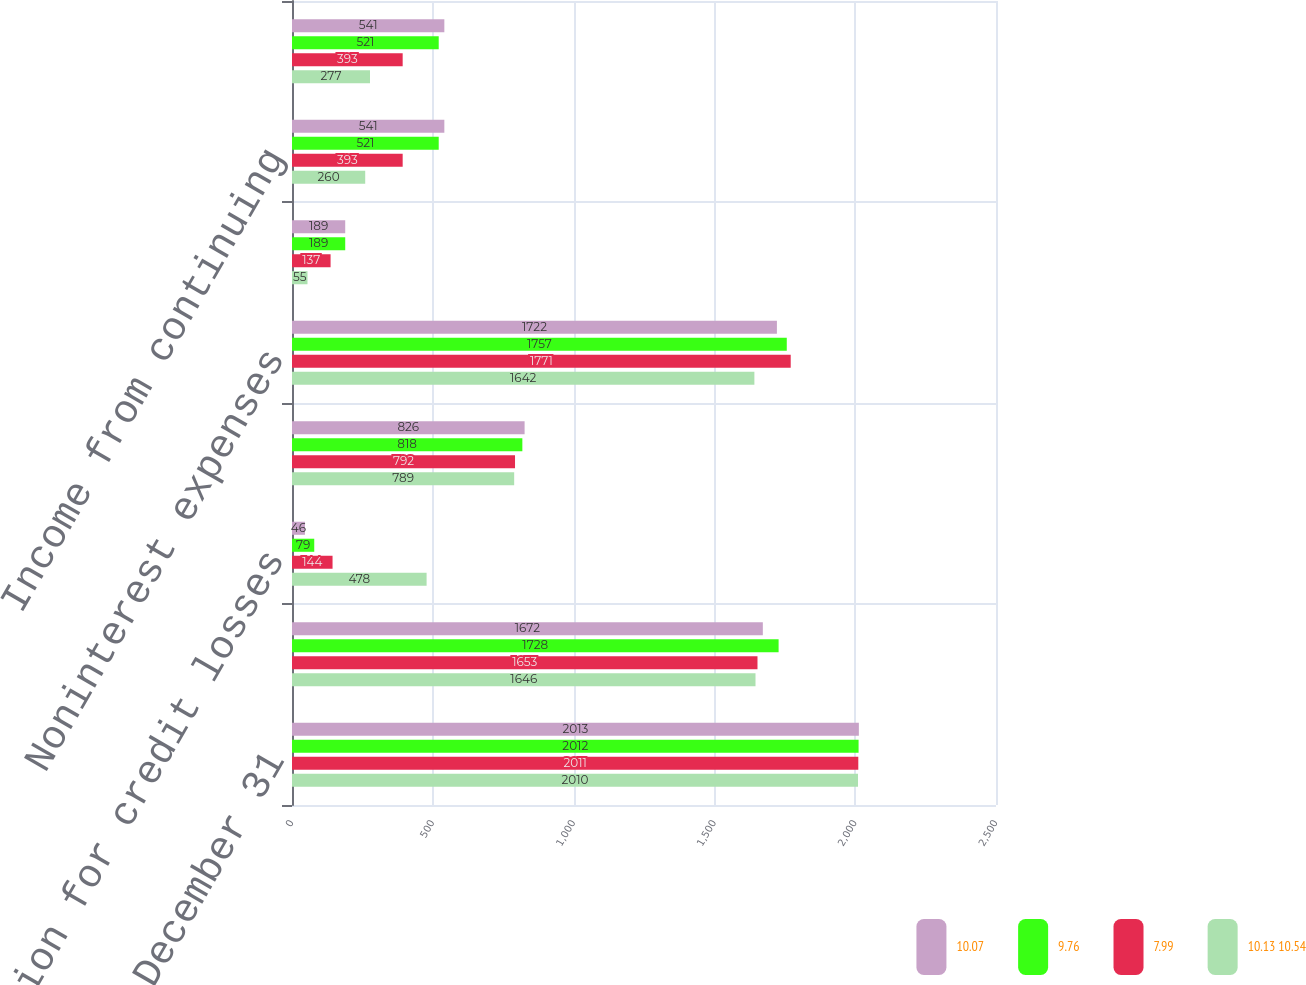Convert chart. <chart><loc_0><loc_0><loc_500><loc_500><stacked_bar_chart><ecel><fcel>Years Ended December 31<fcel>Net interest income<fcel>Provision for credit losses<fcel>Noninterest income<fcel>Noninterest expenses<fcel>Provision (benefit) for income<fcel>Income from continuing<fcel>Net income<nl><fcel>10.07<fcel>2013<fcel>1672<fcel>46<fcel>826<fcel>1722<fcel>189<fcel>541<fcel>541<nl><fcel>9.76<fcel>2012<fcel>1728<fcel>79<fcel>818<fcel>1757<fcel>189<fcel>521<fcel>521<nl><fcel>7.99<fcel>2011<fcel>1653<fcel>144<fcel>792<fcel>1771<fcel>137<fcel>393<fcel>393<nl><fcel>10.13 10.54<fcel>2010<fcel>1646<fcel>478<fcel>789<fcel>1642<fcel>55<fcel>260<fcel>277<nl></chart> 